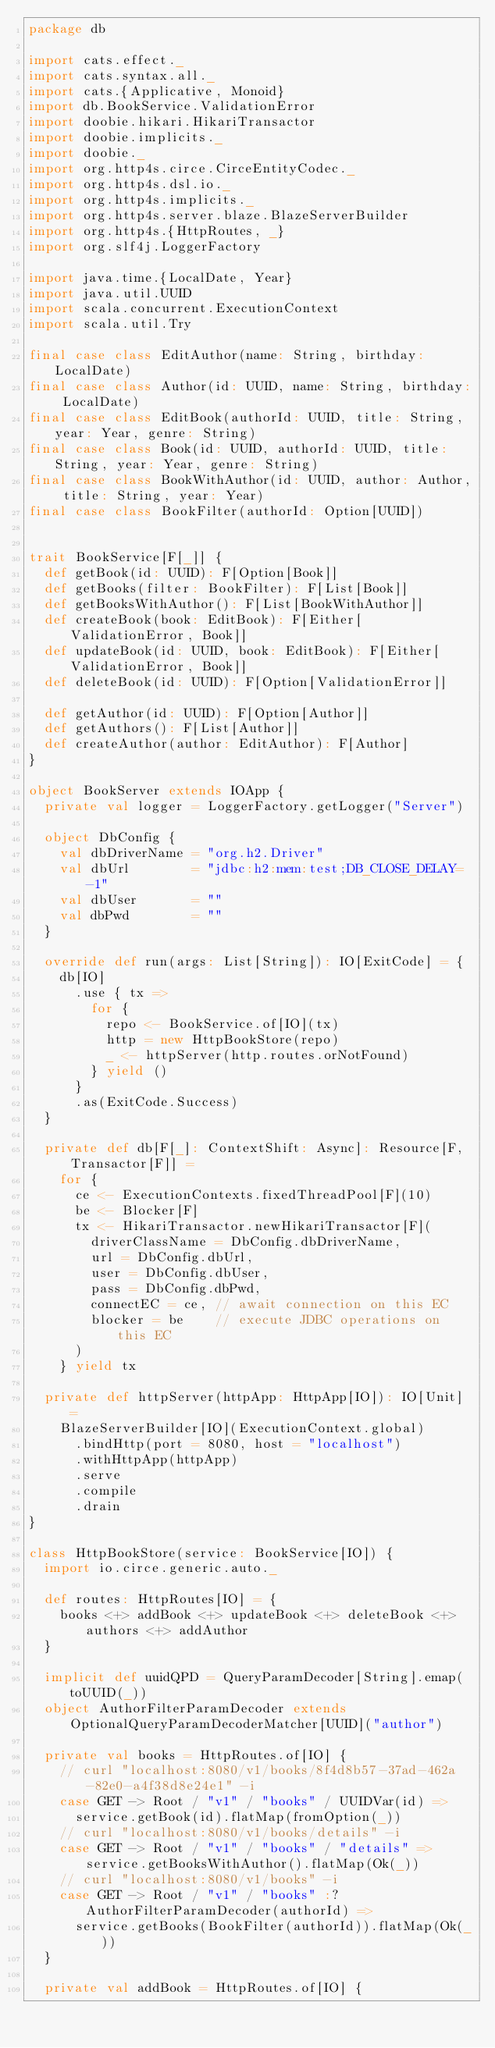Convert code to text. <code><loc_0><loc_0><loc_500><loc_500><_Scala_>package db

import cats.effect._
import cats.syntax.all._
import cats.{Applicative, Monoid}
import db.BookService.ValidationError
import doobie.hikari.HikariTransactor
import doobie.implicits._
import doobie._
import org.http4s.circe.CirceEntityCodec._
import org.http4s.dsl.io._
import org.http4s.implicits._
import org.http4s.server.blaze.BlazeServerBuilder
import org.http4s.{HttpRoutes, _}
import org.slf4j.LoggerFactory

import java.time.{LocalDate, Year}
import java.util.UUID
import scala.concurrent.ExecutionContext
import scala.util.Try

final case class EditAuthor(name: String, birthday: LocalDate)
final case class Author(id: UUID, name: String, birthday: LocalDate)
final case class EditBook(authorId: UUID, title: String, year: Year, genre: String)
final case class Book(id: UUID, authorId: UUID, title: String, year: Year, genre: String)
final case class BookWithAuthor(id: UUID, author: Author, title: String, year: Year)
final case class BookFilter(authorId: Option[UUID])


trait BookService[F[_]] {
  def getBook(id: UUID): F[Option[Book]]
  def getBooks(filter: BookFilter): F[List[Book]]
  def getBooksWithAuthor(): F[List[BookWithAuthor]]
  def createBook(book: EditBook): F[Either[ValidationError, Book]]
  def updateBook(id: UUID, book: EditBook): F[Either[ValidationError, Book]]
  def deleteBook(id: UUID): F[Option[ValidationError]]

  def getAuthor(id: UUID): F[Option[Author]]
  def getAuthors(): F[List[Author]]
  def createAuthor(author: EditAuthor): F[Author]
}

object BookServer extends IOApp {
  private val logger = LoggerFactory.getLogger("Server")

  object DbConfig {
    val dbDriverName = "org.h2.Driver"
    val dbUrl        = "jdbc:h2:mem:test;DB_CLOSE_DELAY=-1"
    val dbUser       = ""
    val dbPwd        = ""
  }

  override def run(args: List[String]): IO[ExitCode] = {
    db[IO]
      .use { tx =>
        for {
          repo <- BookService.of[IO](tx)
          http = new HttpBookStore(repo)
          _ <- httpServer(http.routes.orNotFound)
        } yield ()
      }
      .as(ExitCode.Success)
  }

  private def db[F[_]: ContextShift: Async]: Resource[F, Transactor[F]] =
    for {
      ce <- ExecutionContexts.fixedThreadPool[F](10)
      be <- Blocker[F]
      tx <- HikariTransactor.newHikariTransactor[F](
        driverClassName = DbConfig.dbDriverName,
        url = DbConfig.dbUrl,
        user = DbConfig.dbUser,
        pass = DbConfig.dbPwd,
        connectEC = ce, // await connection on this EC
        blocker = be    // execute JDBC operations on this EC
      )
    } yield tx

  private def httpServer(httpApp: HttpApp[IO]): IO[Unit] =
    BlazeServerBuilder[IO](ExecutionContext.global)
      .bindHttp(port = 8080, host = "localhost")
      .withHttpApp(httpApp)
      .serve
      .compile
      .drain
}

class HttpBookStore(service: BookService[IO]) {
  import io.circe.generic.auto._

  def routes: HttpRoutes[IO] = {
    books <+> addBook <+> updateBook <+> deleteBook <+> authors <+> addAuthor
  }

  implicit def uuidQPD = QueryParamDecoder[String].emap(toUUID(_))
  object AuthorFilterParamDecoder extends OptionalQueryParamDecoderMatcher[UUID]("author")

  private val books = HttpRoutes.of[IO] {
    // curl "localhost:8080/v1/books/8f4d8b57-37ad-462a-82e0-a4f38d8e24e1" -i
    case GET -> Root / "v1" / "books" / UUIDVar(id) =>
      service.getBook(id).flatMap(fromOption(_))
    // curl "localhost:8080/v1/books/details" -i
    case GET -> Root / "v1" / "books" / "details" => service.getBooksWithAuthor().flatMap(Ok(_))
    // curl "localhost:8080/v1/books" -i
    case GET -> Root / "v1" / "books" :? AuthorFilterParamDecoder(authorId) =>
      service.getBooks(BookFilter(authorId)).flatMap(Ok(_))
  }

  private val addBook = HttpRoutes.of[IO] {</code> 